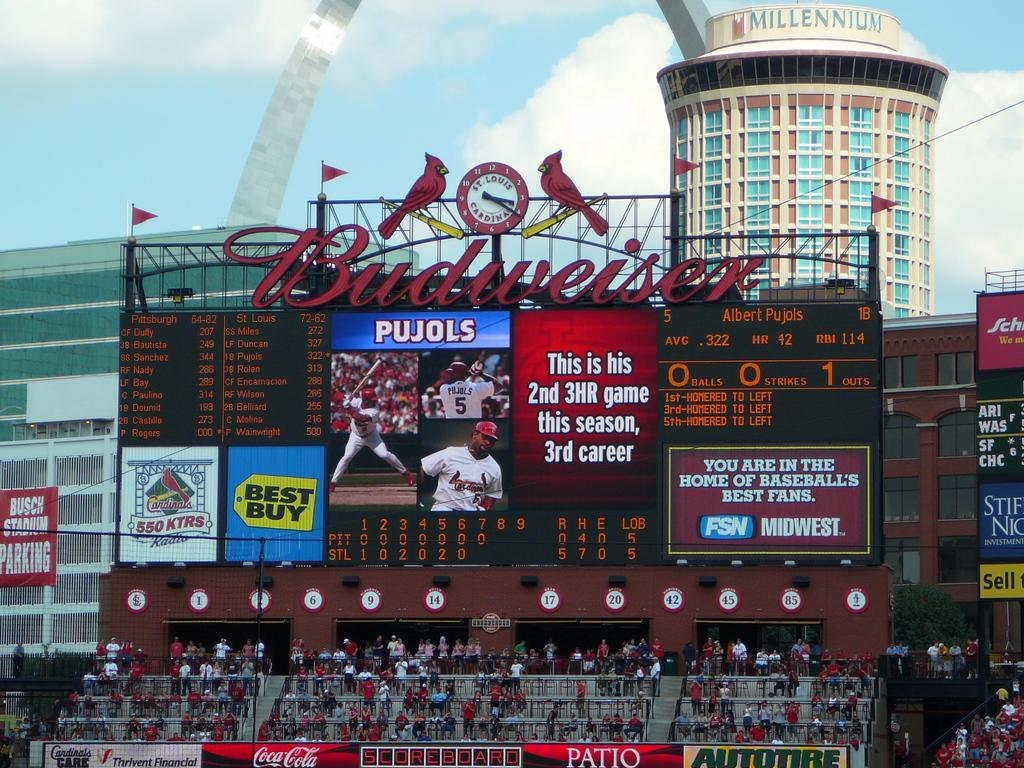<image>
Relay a brief, clear account of the picture shown. A large screen in a stadium has a Budweiser sign above it. 